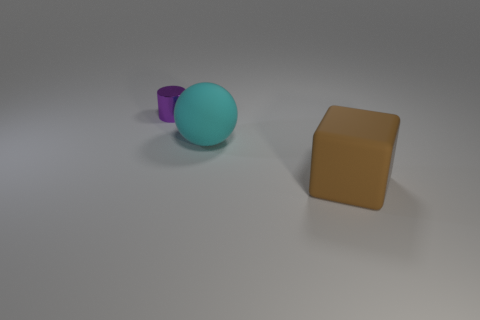Is there anything else that is made of the same material as the small purple cylinder?
Offer a terse response. No. What number of things are to the left of the big rubber thing that is right of the big sphere?
Your response must be concise. 2. How many matte objects are red cylinders or tiny purple objects?
Your answer should be very brief. 0. Are there any big things made of the same material as the big block?
Provide a short and direct response. Yes. How many objects are either objects that are on the left side of the large ball or things on the left side of the big block?
Provide a succinct answer. 2. What number of other objects are there of the same color as the small cylinder?
Provide a short and direct response. 0. What is the cylinder made of?
Ensure brevity in your answer.  Metal. Do the rubber thing in front of the cyan rubber sphere and the big cyan rubber ball have the same size?
Your answer should be compact. Yes. Is there anything else that is the same size as the purple object?
Give a very brief answer. No. Is the number of brown cubes to the right of the big block the same as the number of small metallic objects that are left of the big cyan matte ball?
Offer a very short reply. No. 